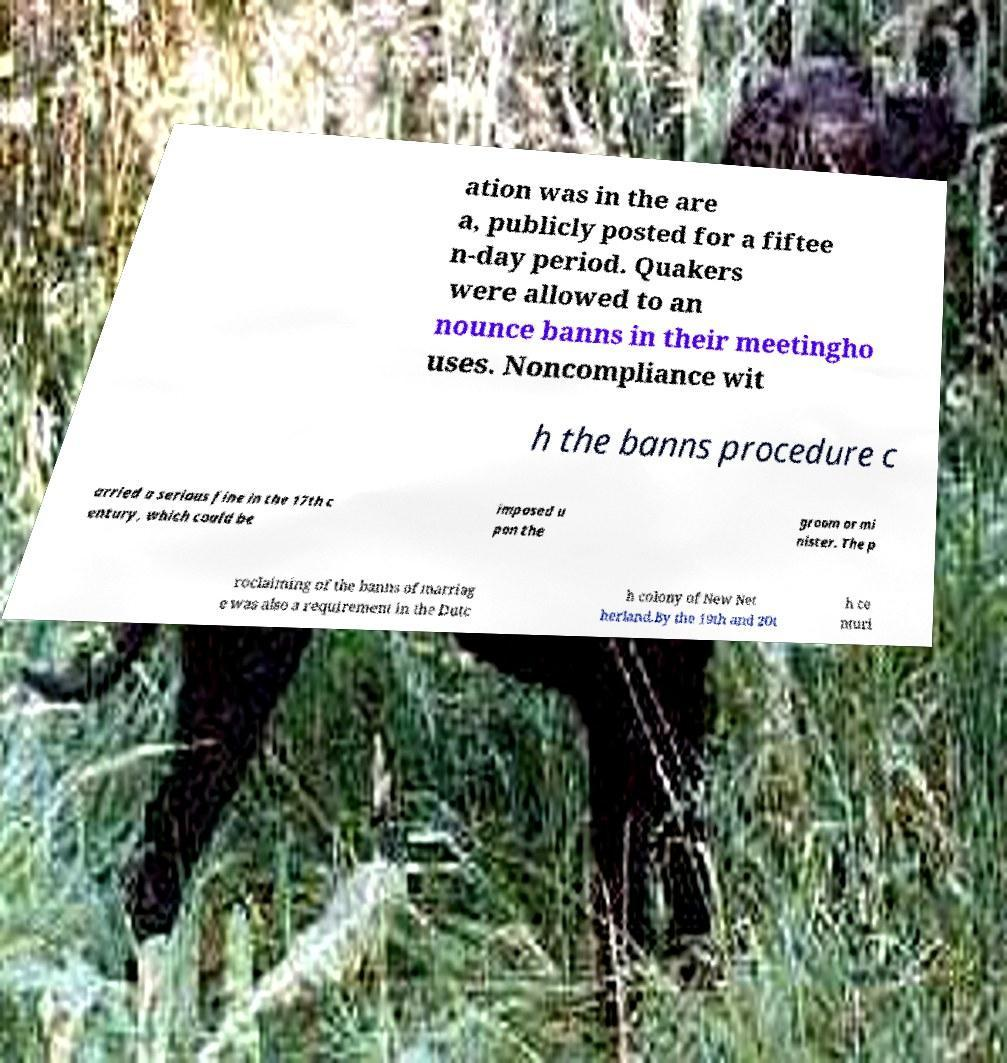There's text embedded in this image that I need extracted. Can you transcribe it verbatim? ation was in the are a, publicly posted for a fiftee n-day period. Quakers were allowed to an nounce banns in their meetingho uses. Noncompliance wit h the banns procedure c arried a serious fine in the 17th c entury, which could be imposed u pon the groom or mi nister. The p roclaiming of the banns of marriag e was also a requirement in the Dutc h colony of New Net herland.By the 19th and 20t h ce nturi 